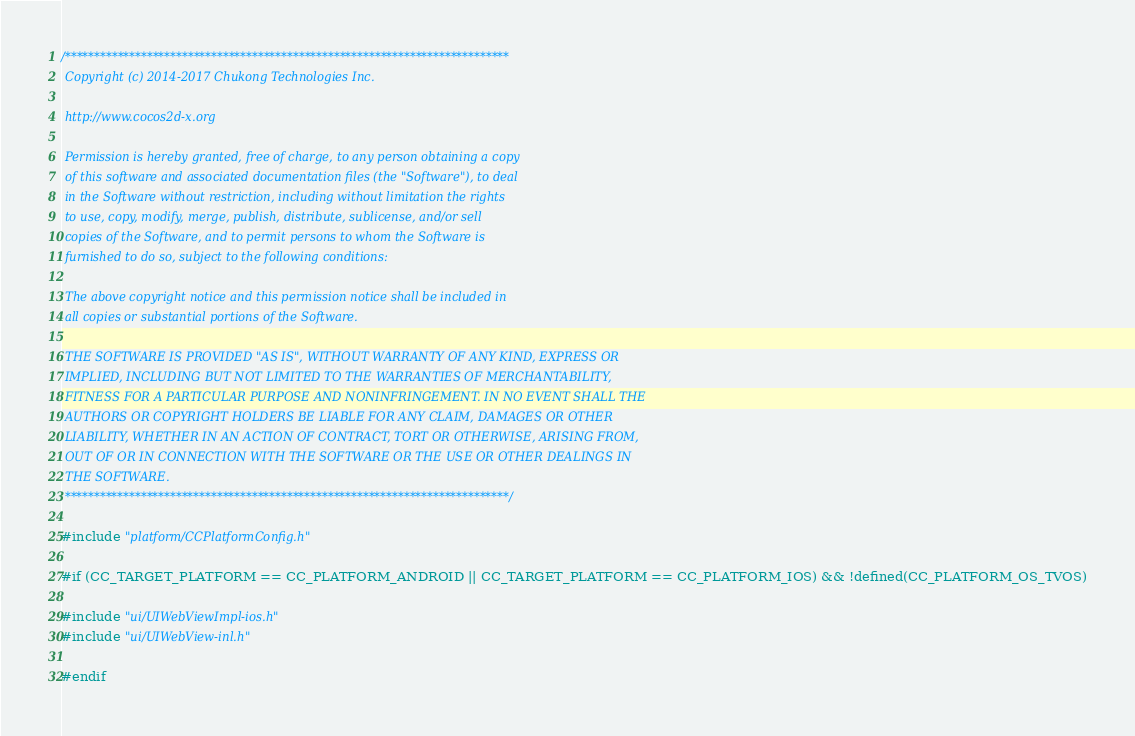<code> <loc_0><loc_0><loc_500><loc_500><_ObjectiveC_>/****************************************************************************
 Copyright (c) 2014-2017 Chukong Technologies Inc.
 
 http://www.cocos2d-x.org
 
 Permission is hereby granted, free of charge, to any person obtaining a copy
 of this software and associated documentation files (the "Software"), to deal
 in the Software without restriction, including without limitation the rights
 to use, copy, modify, merge, publish, distribute, sublicense, and/or sell
 copies of the Software, and to permit persons to whom the Software is
 furnished to do so, subject to the following conditions:
 
 The above copyright notice and this permission notice shall be included in
 all copies or substantial portions of the Software.
 
 THE SOFTWARE IS PROVIDED "AS IS", WITHOUT WARRANTY OF ANY KIND, EXPRESS OR
 IMPLIED, INCLUDING BUT NOT LIMITED TO THE WARRANTIES OF MERCHANTABILITY,
 FITNESS FOR A PARTICULAR PURPOSE AND NONINFRINGEMENT. IN NO EVENT SHALL THE
 AUTHORS OR COPYRIGHT HOLDERS BE LIABLE FOR ANY CLAIM, DAMAGES OR OTHER
 LIABILITY, WHETHER IN AN ACTION OF CONTRACT, TORT OR OTHERWISE, ARISING FROM,
 OUT OF OR IN CONNECTION WITH THE SOFTWARE OR THE USE OR OTHER DEALINGS IN
 THE SOFTWARE.
 ****************************************************************************/

#include "platform/CCPlatformConfig.h"

#if (CC_TARGET_PLATFORM == CC_PLATFORM_ANDROID || CC_TARGET_PLATFORM == CC_PLATFORM_IOS) && !defined(CC_PLATFORM_OS_TVOS)

#include "ui/UIWebViewImpl-ios.h"
#include "ui/UIWebView-inl.h"

#endif
</code> 